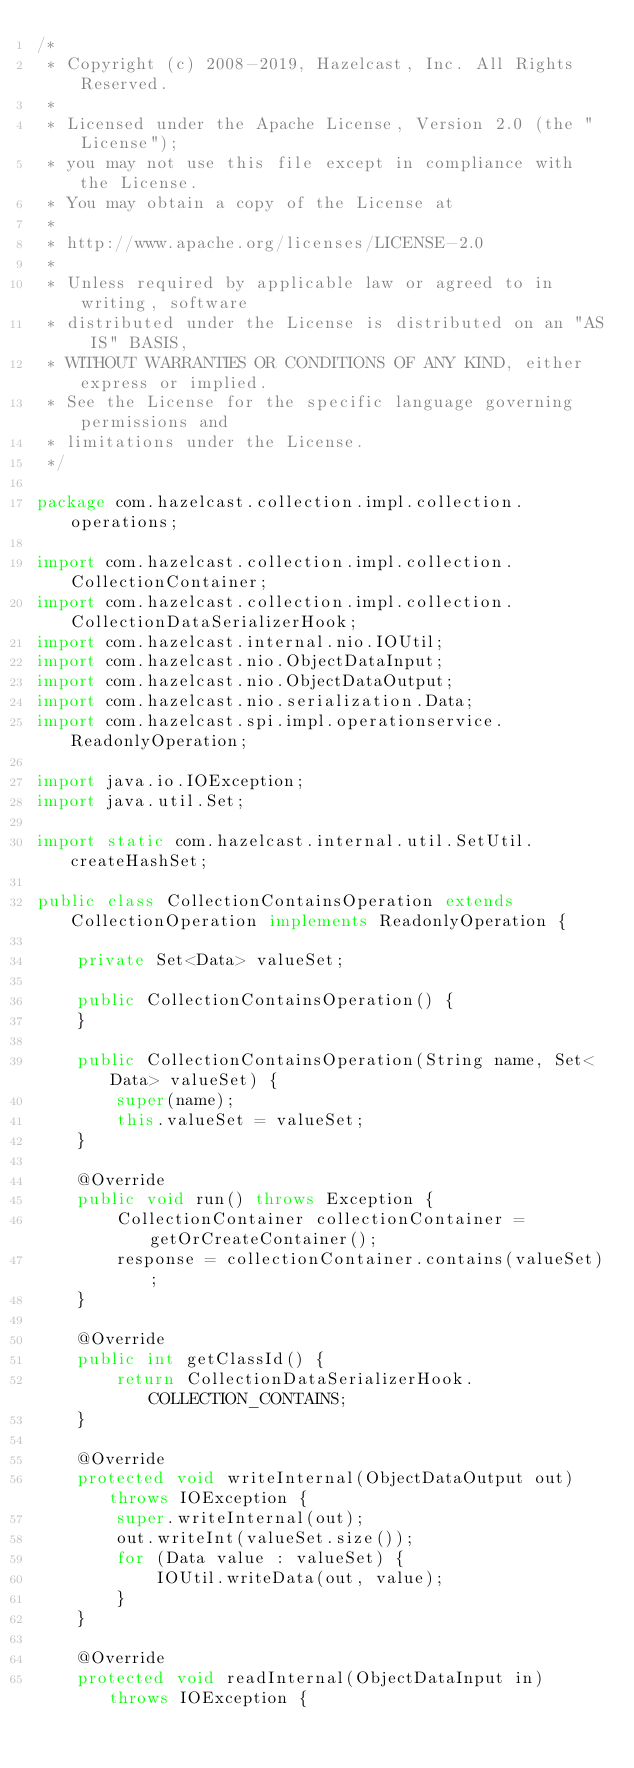<code> <loc_0><loc_0><loc_500><loc_500><_Java_>/*
 * Copyright (c) 2008-2019, Hazelcast, Inc. All Rights Reserved.
 *
 * Licensed under the Apache License, Version 2.0 (the "License");
 * you may not use this file except in compliance with the License.
 * You may obtain a copy of the License at
 *
 * http://www.apache.org/licenses/LICENSE-2.0
 *
 * Unless required by applicable law or agreed to in writing, software
 * distributed under the License is distributed on an "AS IS" BASIS,
 * WITHOUT WARRANTIES OR CONDITIONS OF ANY KIND, either express or implied.
 * See the License for the specific language governing permissions and
 * limitations under the License.
 */

package com.hazelcast.collection.impl.collection.operations;

import com.hazelcast.collection.impl.collection.CollectionContainer;
import com.hazelcast.collection.impl.collection.CollectionDataSerializerHook;
import com.hazelcast.internal.nio.IOUtil;
import com.hazelcast.nio.ObjectDataInput;
import com.hazelcast.nio.ObjectDataOutput;
import com.hazelcast.nio.serialization.Data;
import com.hazelcast.spi.impl.operationservice.ReadonlyOperation;

import java.io.IOException;
import java.util.Set;

import static com.hazelcast.internal.util.SetUtil.createHashSet;

public class CollectionContainsOperation extends CollectionOperation implements ReadonlyOperation {

    private Set<Data> valueSet;

    public CollectionContainsOperation() {
    }

    public CollectionContainsOperation(String name, Set<Data> valueSet) {
        super(name);
        this.valueSet = valueSet;
    }

    @Override
    public void run() throws Exception {
        CollectionContainer collectionContainer = getOrCreateContainer();
        response = collectionContainer.contains(valueSet);
    }

    @Override
    public int getClassId() {
        return CollectionDataSerializerHook.COLLECTION_CONTAINS;
    }

    @Override
    protected void writeInternal(ObjectDataOutput out) throws IOException {
        super.writeInternal(out);
        out.writeInt(valueSet.size());
        for (Data value : valueSet) {
            IOUtil.writeData(out, value);
        }
    }

    @Override
    protected void readInternal(ObjectDataInput in) throws IOException {</code> 